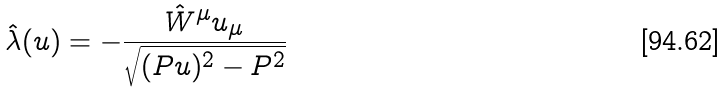<formula> <loc_0><loc_0><loc_500><loc_500>\hat { \lambda } ( u ) = - \frac { \hat { W } ^ { \mu } u _ { \mu } } { \sqrt { ( P u ) ^ { 2 } - P ^ { 2 } } }</formula> 